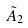Convert formula to latex. <formula><loc_0><loc_0><loc_500><loc_500>\tilde { A } _ { 2 }</formula> 